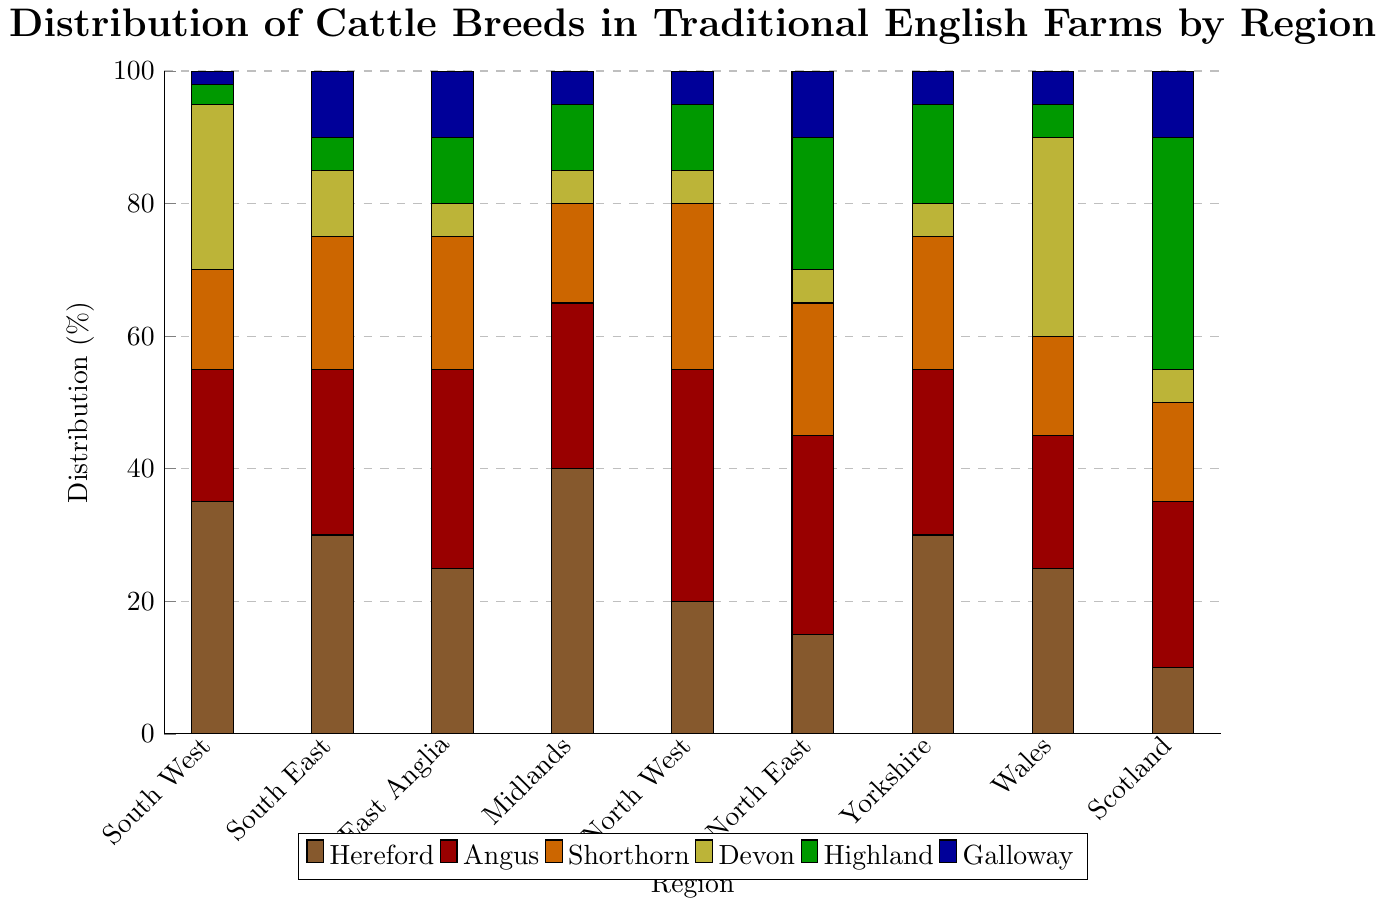Which region has the highest percentage of Highland cattle? From the figure, the region with the highest height in the green bar represents the Highland cattle. The highest green bar is in the Scotland region.
Answer: Scotland What is the combined percentage of Angus and Shorthorn cattle in the North East? To find this, add the percentage of the red bar (Angus) and the orange bar (Shorthorn) for the North East. Red is 30%, and orange is 20%. Therefore, the total is 30% + 20% = 50%.
Answer: 50% Which regions have equal percentages for Devon cattle? By observing the yellow bars representing Devon cattle, both East Anglia and Midlands have bars of equal height, which is 5%.
Answer: East Anglia, Midlands Compare the distribution of Shorthorn cattle between North West and Wales. Which is higher and by how much? In the figure, the orange bar represents Shorthorn cattle. North West has a height of 25%, while Wales has a height of 15%. The difference is 25% - 15% = 10%.
Answer: North West, by 10% Calculate the average percentage of Hereford cattle across all regions. Add the Hereford percentages for each region: 35+30+25+40+20+15+30+25+10 = 230. Since there are 9 regions, average is 230/9 ≈ 25.56%.
Answer: 25.56% Which breed has the least percentage in the South East region? In the figure, the smallest bar in the South East is the yellow bar, which represents Devon. The percentage is 10%.
Answer: Devon Is there any region where the distribution of Galloway cattle is equal to that of Hereford cattle? The blue bars represent Galloway and brown bars represent Hereford. Upon inspection, no such region has equal heights for both bars.
Answer: No What is the total percentage of Galloway cattle in the Midlands, North East, and Yorkshire combined? Sums of the blue bars for Midland, North East, and Yorkshire are 5% + 10% + 5% = 20%.
Answer: 20% Compare the percentage of Devon cattle in Wales and Scotland. By how much does it differ? Yellow bar heights for Devon in Wales and Scotland are 30% and 5%, respectively. The difference is 30% - 5% = 25%.
Answer: By 25% What's the difference in the percentage of Highland cattle between North West and Scotland? Green bar heights for North West and Scotland are 10% and 35%, respectively. The difference is 35% - 10% = 25%.
Answer: 25% 